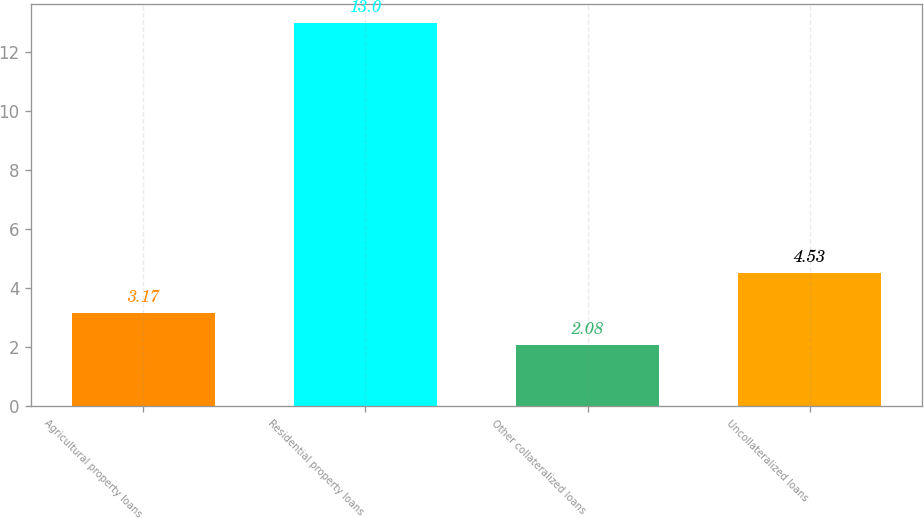<chart> <loc_0><loc_0><loc_500><loc_500><bar_chart><fcel>Agricultural property loans<fcel>Residential property loans<fcel>Other collateralized loans<fcel>Uncollateralized loans<nl><fcel>3.17<fcel>13<fcel>2.08<fcel>4.53<nl></chart> 